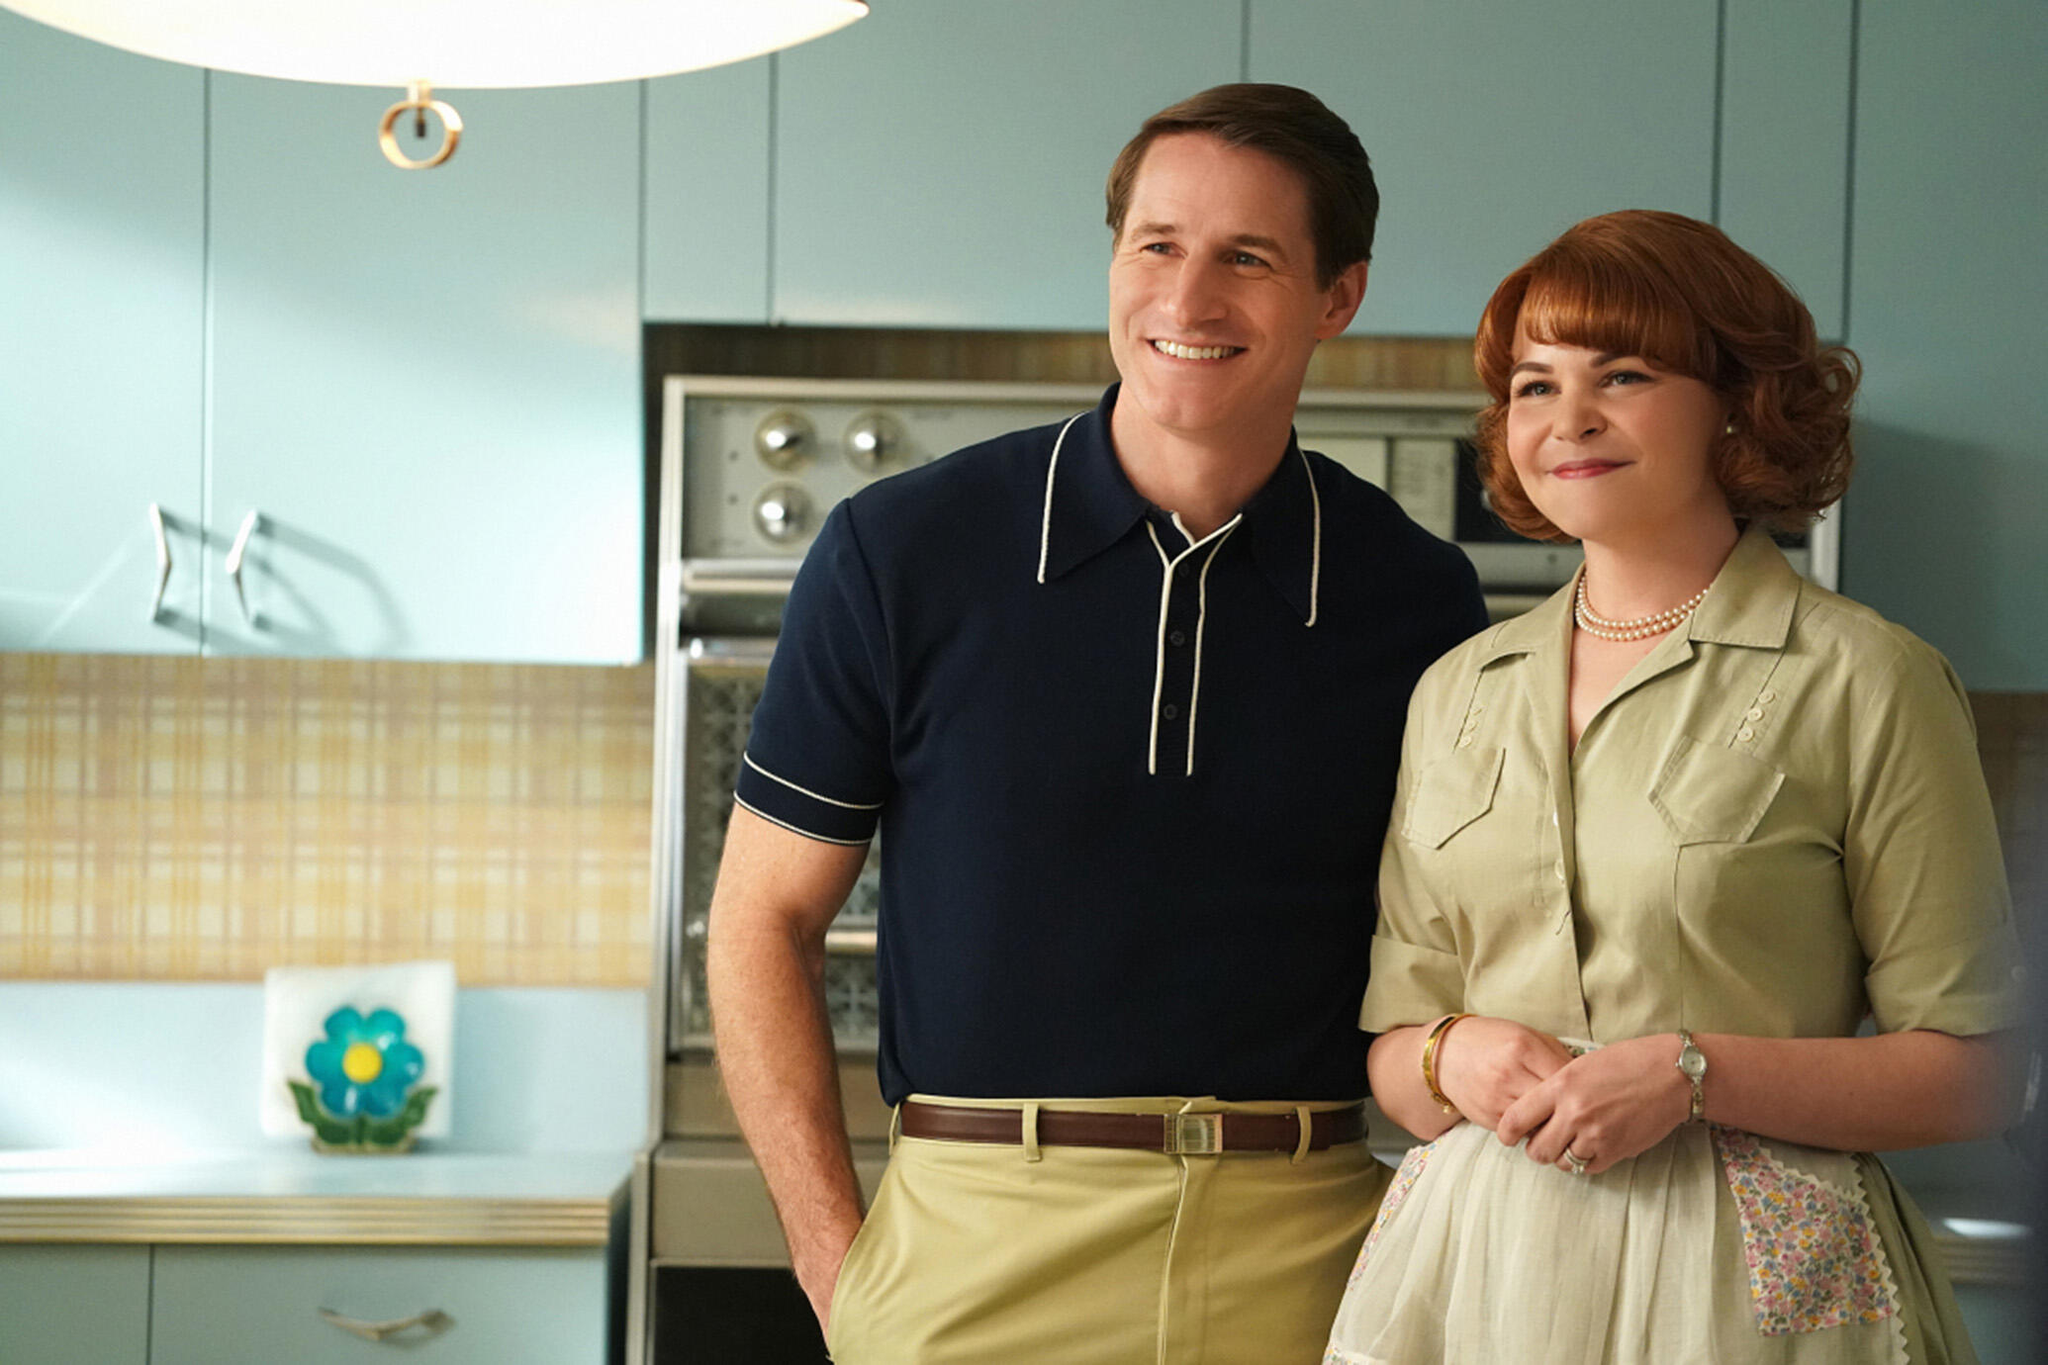Can you describe the emotional tone conveyed by the characters in this image? The characters exude a cheerful and content disposition through their warm smiles and the proximity in which they stand. The setting and their attire complement this sentiment, underscoring a theme of happiness and satisfaction within a homey environment. This portrayal may evoke notions of comfort and familial or close relationships. How does the decor contribute to the atmosphere of the scene? The decor, including the turquoise refrigerator, tiled countertops, and floral accents, contributes significantly to the scene's nostalgic and inviting ambiance. These elements are thoughtfully selected to evoke a sense of warmth and familiarity, typical of the design trends from the era being depicted, reinforcing the overall emotional tone of domestic harmony and happiness. 